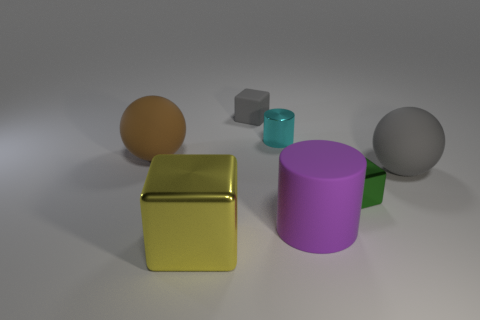Do the big purple rubber object and the small cyan metal thing behind the large metal cube have the same shape?
Offer a very short reply. Yes. Is the number of rubber spheres behind the rubber cube the same as the number of small rubber things on the left side of the yellow object?
Provide a short and direct response. Yes. How many other objects are there of the same material as the brown thing?
Offer a terse response. 3. What number of matte objects are tiny cyan balls or large gray things?
Your answer should be very brief. 1. There is a big thing that is behind the big gray matte ball; is its shape the same as the tiny gray rubber thing?
Provide a short and direct response. No. Are there more tiny matte objects that are to the left of the tiny metal cube than large cyan rubber things?
Provide a short and direct response. Yes. How many blocks are behind the yellow metal thing and in front of the tiny gray rubber thing?
Your response must be concise. 1. There is a small matte block that is to the right of the big rubber thing that is to the left of the tiny cyan object; what color is it?
Offer a terse response. Gray. What number of tiny objects are the same color as the big shiny cube?
Give a very brief answer. 0. There is a small rubber object; is its color the same as the matte ball that is to the right of the small gray matte thing?
Your answer should be very brief. Yes. 